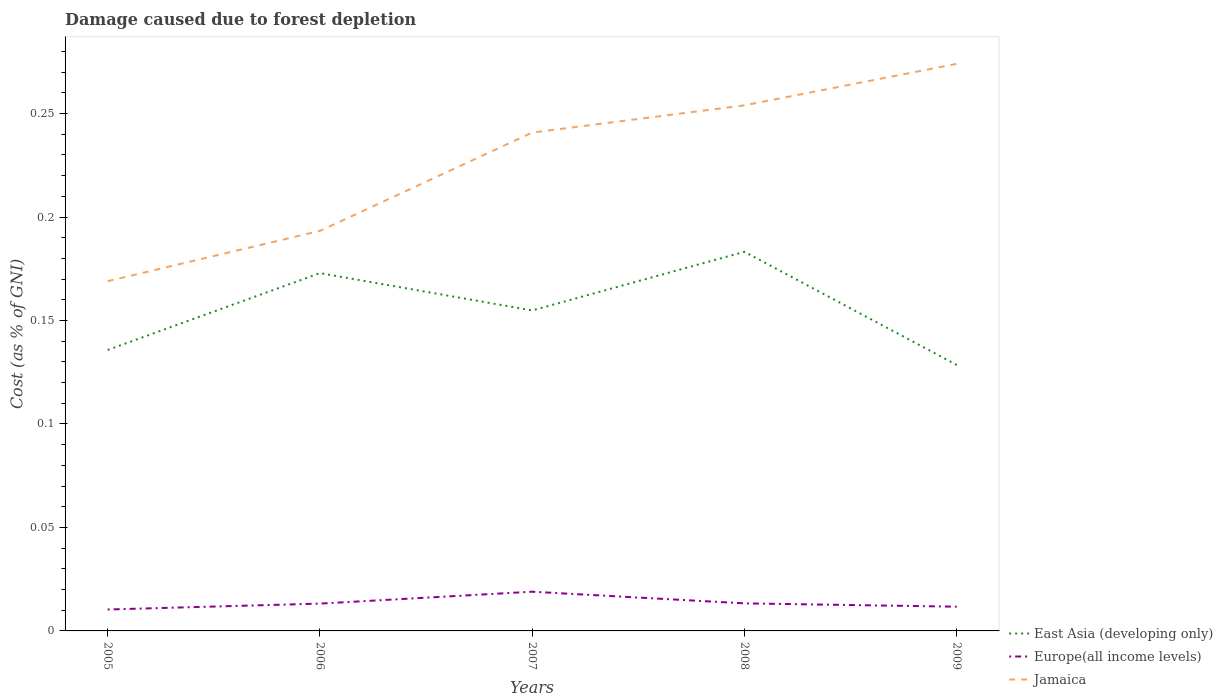Is the number of lines equal to the number of legend labels?
Ensure brevity in your answer.  Yes. Across all years, what is the maximum cost of damage caused due to forest depletion in East Asia (developing only)?
Your answer should be very brief. 0.13. In which year was the cost of damage caused due to forest depletion in Jamaica maximum?
Offer a very short reply. 2005. What is the total cost of damage caused due to forest depletion in East Asia (developing only) in the graph?
Ensure brevity in your answer.  -0.01. What is the difference between the highest and the second highest cost of damage caused due to forest depletion in Jamaica?
Provide a succinct answer. 0.11. How many lines are there?
Keep it short and to the point. 3. What is the difference between two consecutive major ticks on the Y-axis?
Offer a terse response. 0.05. Does the graph contain any zero values?
Give a very brief answer. No. Does the graph contain grids?
Your answer should be very brief. No. Where does the legend appear in the graph?
Ensure brevity in your answer.  Bottom right. How many legend labels are there?
Offer a terse response. 3. What is the title of the graph?
Your response must be concise. Damage caused due to forest depletion. What is the label or title of the X-axis?
Provide a short and direct response. Years. What is the label or title of the Y-axis?
Ensure brevity in your answer.  Cost (as % of GNI). What is the Cost (as % of GNI) of East Asia (developing only) in 2005?
Your response must be concise. 0.14. What is the Cost (as % of GNI) of Europe(all income levels) in 2005?
Provide a succinct answer. 0.01. What is the Cost (as % of GNI) of Jamaica in 2005?
Offer a terse response. 0.17. What is the Cost (as % of GNI) in East Asia (developing only) in 2006?
Ensure brevity in your answer.  0.17. What is the Cost (as % of GNI) in Europe(all income levels) in 2006?
Provide a short and direct response. 0.01. What is the Cost (as % of GNI) of Jamaica in 2006?
Provide a short and direct response. 0.19. What is the Cost (as % of GNI) of East Asia (developing only) in 2007?
Give a very brief answer. 0.15. What is the Cost (as % of GNI) in Europe(all income levels) in 2007?
Keep it short and to the point. 0.02. What is the Cost (as % of GNI) in Jamaica in 2007?
Keep it short and to the point. 0.24. What is the Cost (as % of GNI) of East Asia (developing only) in 2008?
Your response must be concise. 0.18. What is the Cost (as % of GNI) in Europe(all income levels) in 2008?
Your response must be concise. 0.01. What is the Cost (as % of GNI) of Jamaica in 2008?
Make the answer very short. 0.25. What is the Cost (as % of GNI) of East Asia (developing only) in 2009?
Make the answer very short. 0.13. What is the Cost (as % of GNI) of Europe(all income levels) in 2009?
Provide a succinct answer. 0.01. What is the Cost (as % of GNI) in Jamaica in 2009?
Keep it short and to the point. 0.27. Across all years, what is the maximum Cost (as % of GNI) in East Asia (developing only)?
Your answer should be compact. 0.18. Across all years, what is the maximum Cost (as % of GNI) of Europe(all income levels)?
Ensure brevity in your answer.  0.02. Across all years, what is the maximum Cost (as % of GNI) of Jamaica?
Offer a terse response. 0.27. Across all years, what is the minimum Cost (as % of GNI) in East Asia (developing only)?
Provide a succinct answer. 0.13. Across all years, what is the minimum Cost (as % of GNI) of Europe(all income levels)?
Your answer should be very brief. 0.01. Across all years, what is the minimum Cost (as % of GNI) of Jamaica?
Your answer should be very brief. 0.17. What is the total Cost (as % of GNI) in East Asia (developing only) in the graph?
Keep it short and to the point. 0.78. What is the total Cost (as % of GNI) of Europe(all income levels) in the graph?
Offer a terse response. 0.07. What is the total Cost (as % of GNI) in Jamaica in the graph?
Make the answer very short. 1.13. What is the difference between the Cost (as % of GNI) in East Asia (developing only) in 2005 and that in 2006?
Make the answer very short. -0.04. What is the difference between the Cost (as % of GNI) in Europe(all income levels) in 2005 and that in 2006?
Offer a very short reply. -0. What is the difference between the Cost (as % of GNI) of Jamaica in 2005 and that in 2006?
Give a very brief answer. -0.02. What is the difference between the Cost (as % of GNI) of East Asia (developing only) in 2005 and that in 2007?
Provide a short and direct response. -0.02. What is the difference between the Cost (as % of GNI) in Europe(all income levels) in 2005 and that in 2007?
Offer a very short reply. -0.01. What is the difference between the Cost (as % of GNI) in Jamaica in 2005 and that in 2007?
Give a very brief answer. -0.07. What is the difference between the Cost (as % of GNI) in East Asia (developing only) in 2005 and that in 2008?
Offer a very short reply. -0.05. What is the difference between the Cost (as % of GNI) of Europe(all income levels) in 2005 and that in 2008?
Provide a succinct answer. -0. What is the difference between the Cost (as % of GNI) in Jamaica in 2005 and that in 2008?
Your answer should be compact. -0.09. What is the difference between the Cost (as % of GNI) of East Asia (developing only) in 2005 and that in 2009?
Your answer should be compact. 0.01. What is the difference between the Cost (as % of GNI) in Europe(all income levels) in 2005 and that in 2009?
Keep it short and to the point. -0. What is the difference between the Cost (as % of GNI) of Jamaica in 2005 and that in 2009?
Your response must be concise. -0.1. What is the difference between the Cost (as % of GNI) in East Asia (developing only) in 2006 and that in 2007?
Your answer should be very brief. 0.02. What is the difference between the Cost (as % of GNI) of Europe(all income levels) in 2006 and that in 2007?
Give a very brief answer. -0.01. What is the difference between the Cost (as % of GNI) of Jamaica in 2006 and that in 2007?
Ensure brevity in your answer.  -0.05. What is the difference between the Cost (as % of GNI) in East Asia (developing only) in 2006 and that in 2008?
Ensure brevity in your answer.  -0.01. What is the difference between the Cost (as % of GNI) in Europe(all income levels) in 2006 and that in 2008?
Offer a terse response. -0. What is the difference between the Cost (as % of GNI) of Jamaica in 2006 and that in 2008?
Keep it short and to the point. -0.06. What is the difference between the Cost (as % of GNI) of East Asia (developing only) in 2006 and that in 2009?
Make the answer very short. 0.04. What is the difference between the Cost (as % of GNI) of Europe(all income levels) in 2006 and that in 2009?
Make the answer very short. 0. What is the difference between the Cost (as % of GNI) in Jamaica in 2006 and that in 2009?
Your answer should be compact. -0.08. What is the difference between the Cost (as % of GNI) in East Asia (developing only) in 2007 and that in 2008?
Offer a very short reply. -0.03. What is the difference between the Cost (as % of GNI) of Europe(all income levels) in 2007 and that in 2008?
Make the answer very short. 0.01. What is the difference between the Cost (as % of GNI) of Jamaica in 2007 and that in 2008?
Give a very brief answer. -0.01. What is the difference between the Cost (as % of GNI) of East Asia (developing only) in 2007 and that in 2009?
Your answer should be very brief. 0.03. What is the difference between the Cost (as % of GNI) of Europe(all income levels) in 2007 and that in 2009?
Your answer should be compact. 0.01. What is the difference between the Cost (as % of GNI) of Jamaica in 2007 and that in 2009?
Your answer should be very brief. -0.03. What is the difference between the Cost (as % of GNI) of East Asia (developing only) in 2008 and that in 2009?
Your response must be concise. 0.05. What is the difference between the Cost (as % of GNI) in Europe(all income levels) in 2008 and that in 2009?
Your response must be concise. 0. What is the difference between the Cost (as % of GNI) in Jamaica in 2008 and that in 2009?
Keep it short and to the point. -0.02. What is the difference between the Cost (as % of GNI) in East Asia (developing only) in 2005 and the Cost (as % of GNI) in Europe(all income levels) in 2006?
Give a very brief answer. 0.12. What is the difference between the Cost (as % of GNI) in East Asia (developing only) in 2005 and the Cost (as % of GNI) in Jamaica in 2006?
Offer a terse response. -0.06. What is the difference between the Cost (as % of GNI) in Europe(all income levels) in 2005 and the Cost (as % of GNI) in Jamaica in 2006?
Provide a short and direct response. -0.18. What is the difference between the Cost (as % of GNI) in East Asia (developing only) in 2005 and the Cost (as % of GNI) in Europe(all income levels) in 2007?
Offer a very short reply. 0.12. What is the difference between the Cost (as % of GNI) in East Asia (developing only) in 2005 and the Cost (as % of GNI) in Jamaica in 2007?
Your answer should be compact. -0.1. What is the difference between the Cost (as % of GNI) in Europe(all income levels) in 2005 and the Cost (as % of GNI) in Jamaica in 2007?
Offer a terse response. -0.23. What is the difference between the Cost (as % of GNI) in East Asia (developing only) in 2005 and the Cost (as % of GNI) in Europe(all income levels) in 2008?
Your response must be concise. 0.12. What is the difference between the Cost (as % of GNI) of East Asia (developing only) in 2005 and the Cost (as % of GNI) of Jamaica in 2008?
Your answer should be compact. -0.12. What is the difference between the Cost (as % of GNI) in Europe(all income levels) in 2005 and the Cost (as % of GNI) in Jamaica in 2008?
Your answer should be compact. -0.24. What is the difference between the Cost (as % of GNI) of East Asia (developing only) in 2005 and the Cost (as % of GNI) of Europe(all income levels) in 2009?
Offer a terse response. 0.12. What is the difference between the Cost (as % of GNI) in East Asia (developing only) in 2005 and the Cost (as % of GNI) in Jamaica in 2009?
Keep it short and to the point. -0.14. What is the difference between the Cost (as % of GNI) in Europe(all income levels) in 2005 and the Cost (as % of GNI) in Jamaica in 2009?
Offer a very short reply. -0.26. What is the difference between the Cost (as % of GNI) of East Asia (developing only) in 2006 and the Cost (as % of GNI) of Europe(all income levels) in 2007?
Provide a succinct answer. 0.15. What is the difference between the Cost (as % of GNI) of East Asia (developing only) in 2006 and the Cost (as % of GNI) of Jamaica in 2007?
Offer a very short reply. -0.07. What is the difference between the Cost (as % of GNI) in Europe(all income levels) in 2006 and the Cost (as % of GNI) in Jamaica in 2007?
Your response must be concise. -0.23. What is the difference between the Cost (as % of GNI) of East Asia (developing only) in 2006 and the Cost (as % of GNI) of Europe(all income levels) in 2008?
Offer a terse response. 0.16. What is the difference between the Cost (as % of GNI) in East Asia (developing only) in 2006 and the Cost (as % of GNI) in Jamaica in 2008?
Ensure brevity in your answer.  -0.08. What is the difference between the Cost (as % of GNI) in Europe(all income levels) in 2006 and the Cost (as % of GNI) in Jamaica in 2008?
Offer a terse response. -0.24. What is the difference between the Cost (as % of GNI) in East Asia (developing only) in 2006 and the Cost (as % of GNI) in Europe(all income levels) in 2009?
Your response must be concise. 0.16. What is the difference between the Cost (as % of GNI) of East Asia (developing only) in 2006 and the Cost (as % of GNI) of Jamaica in 2009?
Your answer should be very brief. -0.1. What is the difference between the Cost (as % of GNI) in Europe(all income levels) in 2006 and the Cost (as % of GNI) in Jamaica in 2009?
Keep it short and to the point. -0.26. What is the difference between the Cost (as % of GNI) in East Asia (developing only) in 2007 and the Cost (as % of GNI) in Europe(all income levels) in 2008?
Keep it short and to the point. 0.14. What is the difference between the Cost (as % of GNI) in East Asia (developing only) in 2007 and the Cost (as % of GNI) in Jamaica in 2008?
Provide a succinct answer. -0.1. What is the difference between the Cost (as % of GNI) in Europe(all income levels) in 2007 and the Cost (as % of GNI) in Jamaica in 2008?
Your response must be concise. -0.23. What is the difference between the Cost (as % of GNI) of East Asia (developing only) in 2007 and the Cost (as % of GNI) of Europe(all income levels) in 2009?
Your answer should be very brief. 0.14. What is the difference between the Cost (as % of GNI) of East Asia (developing only) in 2007 and the Cost (as % of GNI) of Jamaica in 2009?
Make the answer very short. -0.12. What is the difference between the Cost (as % of GNI) in Europe(all income levels) in 2007 and the Cost (as % of GNI) in Jamaica in 2009?
Your response must be concise. -0.26. What is the difference between the Cost (as % of GNI) of East Asia (developing only) in 2008 and the Cost (as % of GNI) of Europe(all income levels) in 2009?
Your response must be concise. 0.17. What is the difference between the Cost (as % of GNI) of East Asia (developing only) in 2008 and the Cost (as % of GNI) of Jamaica in 2009?
Keep it short and to the point. -0.09. What is the difference between the Cost (as % of GNI) of Europe(all income levels) in 2008 and the Cost (as % of GNI) of Jamaica in 2009?
Your answer should be compact. -0.26. What is the average Cost (as % of GNI) of East Asia (developing only) per year?
Your response must be concise. 0.16. What is the average Cost (as % of GNI) in Europe(all income levels) per year?
Offer a very short reply. 0.01. What is the average Cost (as % of GNI) in Jamaica per year?
Ensure brevity in your answer.  0.23. In the year 2005, what is the difference between the Cost (as % of GNI) of East Asia (developing only) and Cost (as % of GNI) of Europe(all income levels)?
Your answer should be compact. 0.13. In the year 2005, what is the difference between the Cost (as % of GNI) in East Asia (developing only) and Cost (as % of GNI) in Jamaica?
Offer a terse response. -0.03. In the year 2005, what is the difference between the Cost (as % of GNI) in Europe(all income levels) and Cost (as % of GNI) in Jamaica?
Your response must be concise. -0.16. In the year 2006, what is the difference between the Cost (as % of GNI) in East Asia (developing only) and Cost (as % of GNI) in Europe(all income levels)?
Your answer should be very brief. 0.16. In the year 2006, what is the difference between the Cost (as % of GNI) of East Asia (developing only) and Cost (as % of GNI) of Jamaica?
Provide a succinct answer. -0.02. In the year 2006, what is the difference between the Cost (as % of GNI) of Europe(all income levels) and Cost (as % of GNI) of Jamaica?
Keep it short and to the point. -0.18. In the year 2007, what is the difference between the Cost (as % of GNI) of East Asia (developing only) and Cost (as % of GNI) of Europe(all income levels)?
Your response must be concise. 0.14. In the year 2007, what is the difference between the Cost (as % of GNI) in East Asia (developing only) and Cost (as % of GNI) in Jamaica?
Ensure brevity in your answer.  -0.09. In the year 2007, what is the difference between the Cost (as % of GNI) of Europe(all income levels) and Cost (as % of GNI) of Jamaica?
Make the answer very short. -0.22. In the year 2008, what is the difference between the Cost (as % of GNI) of East Asia (developing only) and Cost (as % of GNI) of Europe(all income levels)?
Provide a succinct answer. 0.17. In the year 2008, what is the difference between the Cost (as % of GNI) of East Asia (developing only) and Cost (as % of GNI) of Jamaica?
Offer a very short reply. -0.07. In the year 2008, what is the difference between the Cost (as % of GNI) of Europe(all income levels) and Cost (as % of GNI) of Jamaica?
Your answer should be very brief. -0.24. In the year 2009, what is the difference between the Cost (as % of GNI) in East Asia (developing only) and Cost (as % of GNI) in Europe(all income levels)?
Keep it short and to the point. 0.12. In the year 2009, what is the difference between the Cost (as % of GNI) in East Asia (developing only) and Cost (as % of GNI) in Jamaica?
Offer a very short reply. -0.15. In the year 2009, what is the difference between the Cost (as % of GNI) of Europe(all income levels) and Cost (as % of GNI) of Jamaica?
Your answer should be compact. -0.26. What is the ratio of the Cost (as % of GNI) in East Asia (developing only) in 2005 to that in 2006?
Make the answer very short. 0.79. What is the ratio of the Cost (as % of GNI) of Europe(all income levels) in 2005 to that in 2006?
Your answer should be very brief. 0.78. What is the ratio of the Cost (as % of GNI) of Jamaica in 2005 to that in 2006?
Give a very brief answer. 0.87. What is the ratio of the Cost (as % of GNI) of East Asia (developing only) in 2005 to that in 2007?
Your answer should be very brief. 0.88. What is the ratio of the Cost (as % of GNI) in Europe(all income levels) in 2005 to that in 2007?
Give a very brief answer. 0.55. What is the ratio of the Cost (as % of GNI) in Jamaica in 2005 to that in 2007?
Your answer should be compact. 0.7. What is the ratio of the Cost (as % of GNI) in East Asia (developing only) in 2005 to that in 2008?
Your response must be concise. 0.74. What is the ratio of the Cost (as % of GNI) of Europe(all income levels) in 2005 to that in 2008?
Make the answer very short. 0.78. What is the ratio of the Cost (as % of GNI) of Jamaica in 2005 to that in 2008?
Your answer should be compact. 0.67. What is the ratio of the Cost (as % of GNI) of East Asia (developing only) in 2005 to that in 2009?
Offer a very short reply. 1.06. What is the ratio of the Cost (as % of GNI) in Europe(all income levels) in 2005 to that in 2009?
Keep it short and to the point. 0.88. What is the ratio of the Cost (as % of GNI) in Jamaica in 2005 to that in 2009?
Give a very brief answer. 0.62. What is the ratio of the Cost (as % of GNI) of East Asia (developing only) in 2006 to that in 2007?
Keep it short and to the point. 1.12. What is the ratio of the Cost (as % of GNI) in Europe(all income levels) in 2006 to that in 2007?
Give a very brief answer. 0.7. What is the ratio of the Cost (as % of GNI) in Jamaica in 2006 to that in 2007?
Your answer should be compact. 0.8. What is the ratio of the Cost (as % of GNI) in East Asia (developing only) in 2006 to that in 2008?
Give a very brief answer. 0.94. What is the ratio of the Cost (as % of GNI) in Europe(all income levels) in 2006 to that in 2008?
Make the answer very short. 0.99. What is the ratio of the Cost (as % of GNI) in Jamaica in 2006 to that in 2008?
Offer a terse response. 0.76. What is the ratio of the Cost (as % of GNI) in East Asia (developing only) in 2006 to that in 2009?
Make the answer very short. 1.35. What is the ratio of the Cost (as % of GNI) in Europe(all income levels) in 2006 to that in 2009?
Make the answer very short. 1.13. What is the ratio of the Cost (as % of GNI) of Jamaica in 2006 to that in 2009?
Offer a terse response. 0.71. What is the ratio of the Cost (as % of GNI) of East Asia (developing only) in 2007 to that in 2008?
Your answer should be very brief. 0.85. What is the ratio of the Cost (as % of GNI) of Europe(all income levels) in 2007 to that in 2008?
Provide a short and direct response. 1.42. What is the ratio of the Cost (as % of GNI) in Jamaica in 2007 to that in 2008?
Make the answer very short. 0.95. What is the ratio of the Cost (as % of GNI) in East Asia (developing only) in 2007 to that in 2009?
Your response must be concise. 1.2. What is the ratio of the Cost (as % of GNI) in Europe(all income levels) in 2007 to that in 2009?
Your response must be concise. 1.62. What is the ratio of the Cost (as % of GNI) in Jamaica in 2007 to that in 2009?
Offer a terse response. 0.88. What is the ratio of the Cost (as % of GNI) in East Asia (developing only) in 2008 to that in 2009?
Your answer should be compact. 1.43. What is the ratio of the Cost (as % of GNI) of Europe(all income levels) in 2008 to that in 2009?
Ensure brevity in your answer.  1.14. What is the ratio of the Cost (as % of GNI) in Jamaica in 2008 to that in 2009?
Provide a short and direct response. 0.93. What is the difference between the highest and the second highest Cost (as % of GNI) of East Asia (developing only)?
Your response must be concise. 0.01. What is the difference between the highest and the second highest Cost (as % of GNI) of Europe(all income levels)?
Make the answer very short. 0.01. What is the difference between the highest and the lowest Cost (as % of GNI) of East Asia (developing only)?
Make the answer very short. 0.05. What is the difference between the highest and the lowest Cost (as % of GNI) in Europe(all income levels)?
Make the answer very short. 0.01. What is the difference between the highest and the lowest Cost (as % of GNI) of Jamaica?
Your response must be concise. 0.1. 